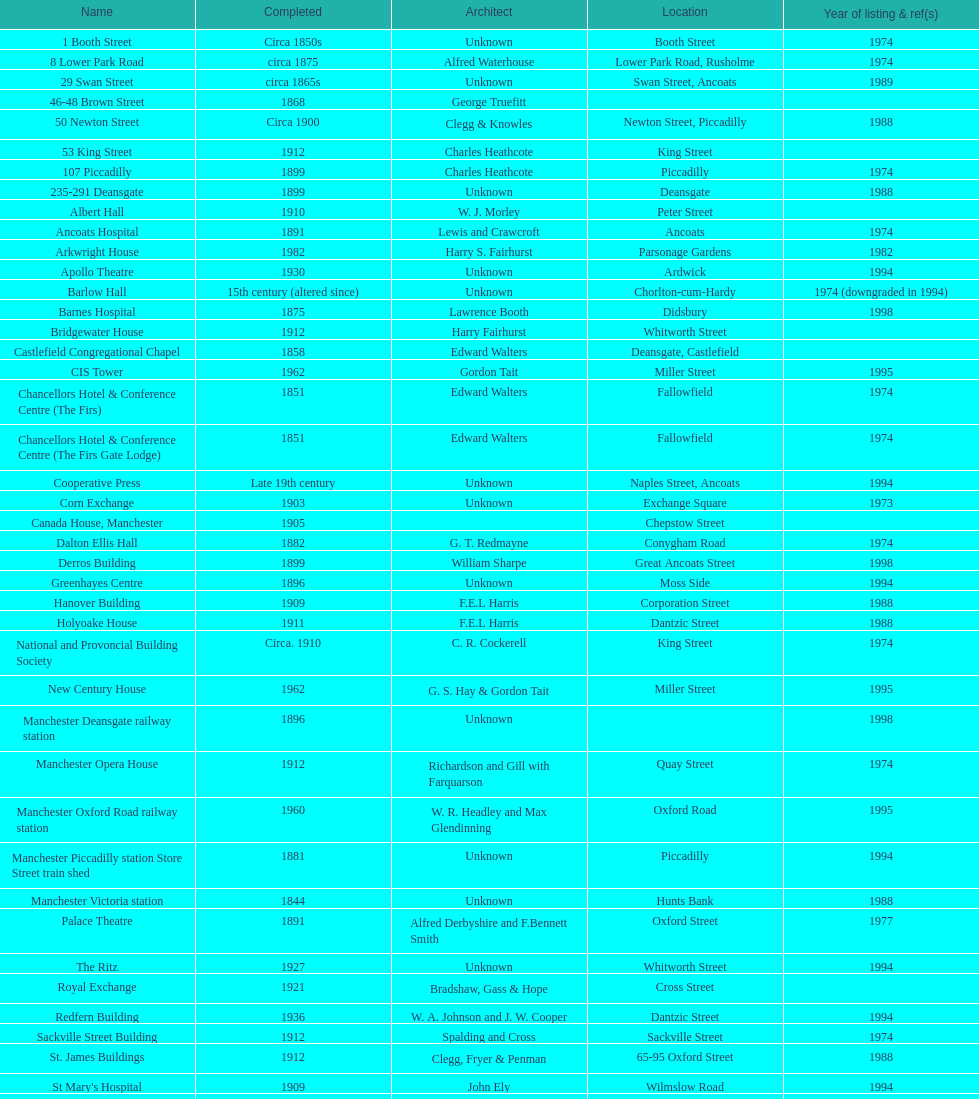What two buildings were classified as listed before the year 1974? The Old Wellington Inn, Smithfield Market Hall. 